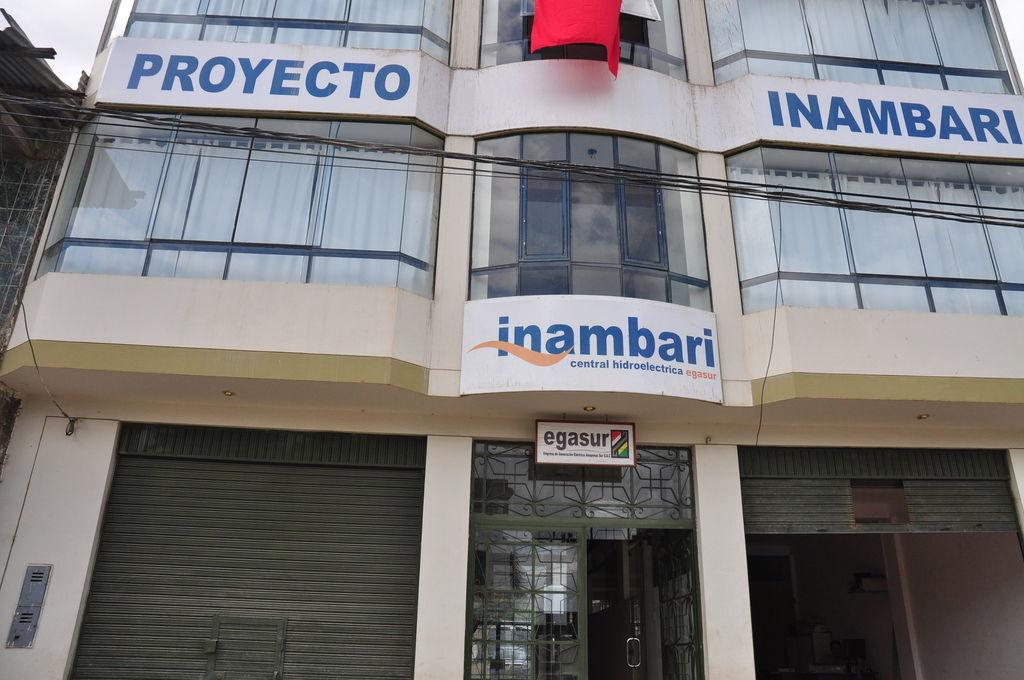What type of structure is present in the image? There is a building in the image. Where is the entrance to the building located? There is an entrance door below the building. What feature is present on the other side of the entrance door? There are two shutters on the other side of the door. How many openings for light and ventilation are visible in the building? There are many windows in the building. What company is located inside the building in the image? The image does not provide any information about a company being located inside the building. 